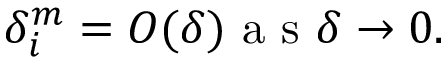Convert formula to latex. <formula><loc_0><loc_0><loc_500><loc_500>\delta _ { i } ^ { m } = O ( \delta ) a s \delta \rightarrow 0 .</formula> 